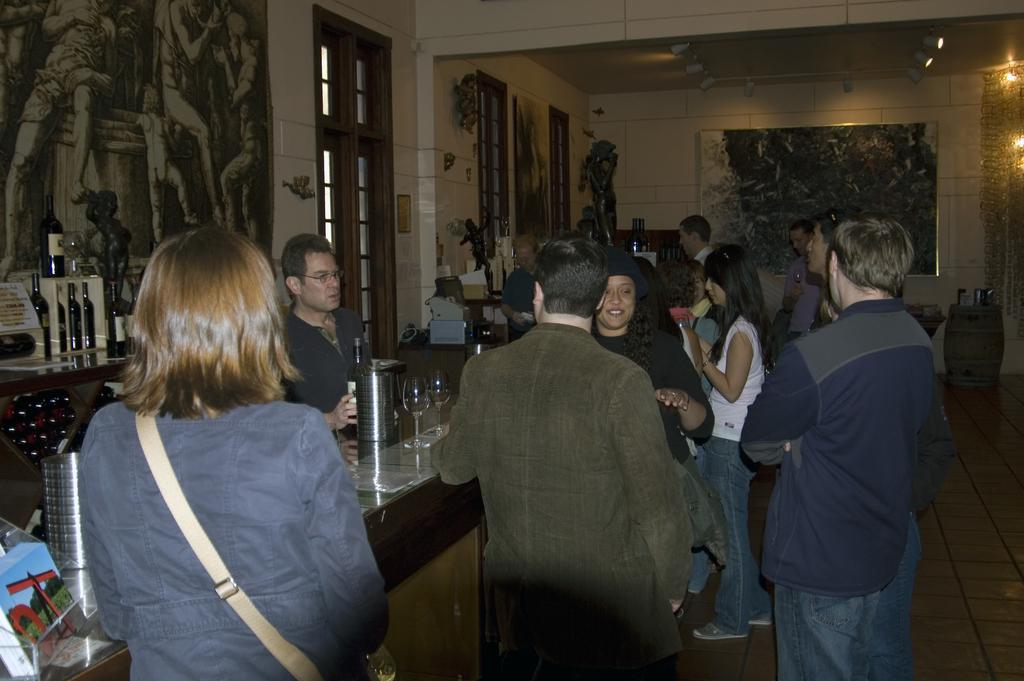What is the main subject of the image? The main subject of the image is a group of people. Where are the people located in the image? The group of people is standing at a bar counter. Who is serving the people at the bar counter? There is a bartender present in the image. What type of insurance policy do the dolls in the image have? There are no dolls present in the image, so it is not possible to determine if they have any insurance policy. 